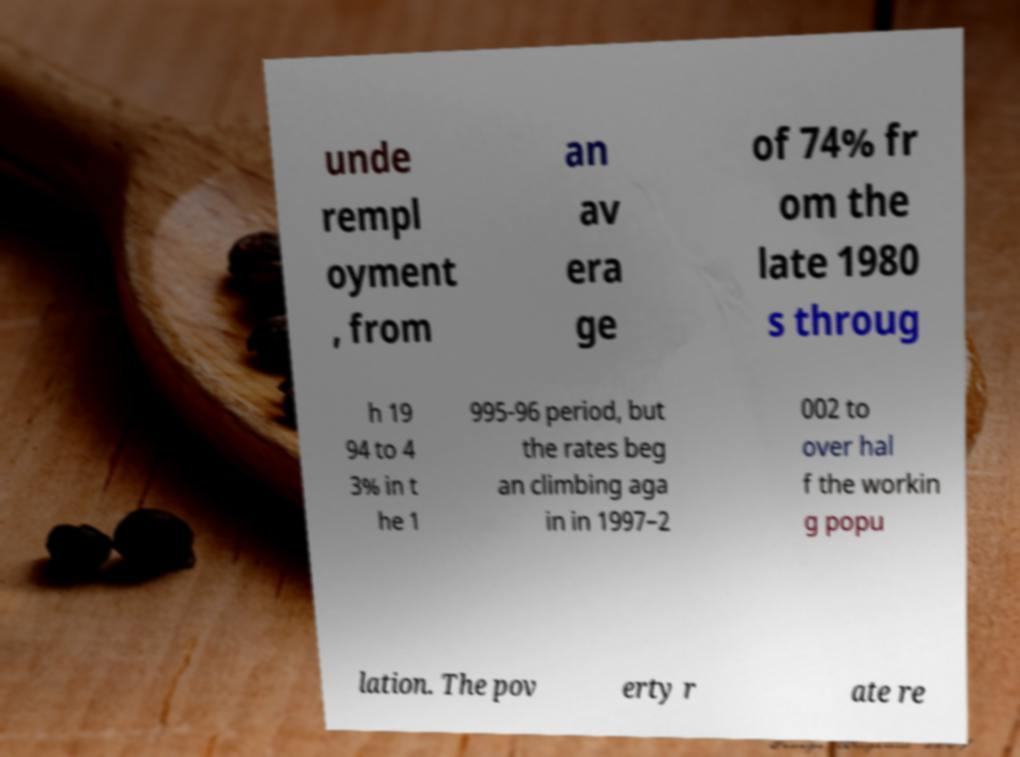Please identify and transcribe the text found in this image. unde rempl oyment , from an av era ge of 74% fr om the late 1980 s throug h 19 94 to 4 3% in t he 1 995-96 period, but the rates beg an climbing aga in in 1997–2 002 to over hal f the workin g popu lation. The pov erty r ate re 